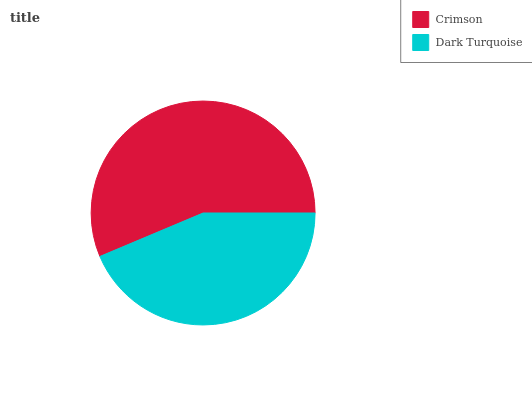Is Dark Turquoise the minimum?
Answer yes or no. Yes. Is Crimson the maximum?
Answer yes or no. Yes. Is Dark Turquoise the maximum?
Answer yes or no. No. Is Crimson greater than Dark Turquoise?
Answer yes or no. Yes. Is Dark Turquoise less than Crimson?
Answer yes or no. Yes. Is Dark Turquoise greater than Crimson?
Answer yes or no. No. Is Crimson less than Dark Turquoise?
Answer yes or no. No. Is Crimson the high median?
Answer yes or no. Yes. Is Dark Turquoise the low median?
Answer yes or no. Yes. Is Dark Turquoise the high median?
Answer yes or no. No. Is Crimson the low median?
Answer yes or no. No. 